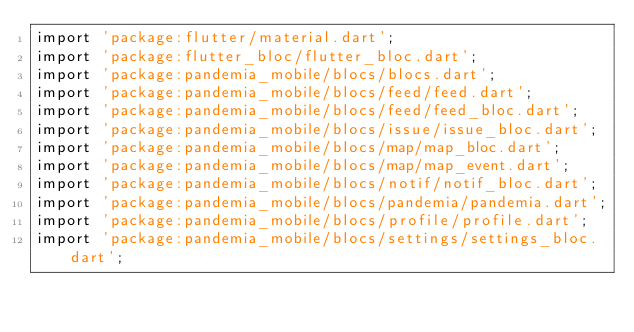Convert code to text. <code><loc_0><loc_0><loc_500><loc_500><_Dart_>import 'package:flutter/material.dart';
import 'package:flutter_bloc/flutter_bloc.dart';
import 'package:pandemia_mobile/blocs/blocs.dart';
import 'package:pandemia_mobile/blocs/feed/feed.dart';
import 'package:pandemia_mobile/blocs/feed/feed_bloc.dart';
import 'package:pandemia_mobile/blocs/issue/issue_bloc.dart';
import 'package:pandemia_mobile/blocs/map/map_bloc.dart';
import 'package:pandemia_mobile/blocs/map/map_event.dart';
import 'package:pandemia_mobile/blocs/notif/notif_bloc.dart';
import 'package:pandemia_mobile/blocs/pandemia/pandemia.dart';
import 'package:pandemia_mobile/blocs/profile/profile.dart';
import 'package:pandemia_mobile/blocs/settings/settings_bloc.dart';</code> 